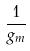Convert formula to latex. <formula><loc_0><loc_0><loc_500><loc_500>\frac { 1 } { g _ { m } }</formula> 